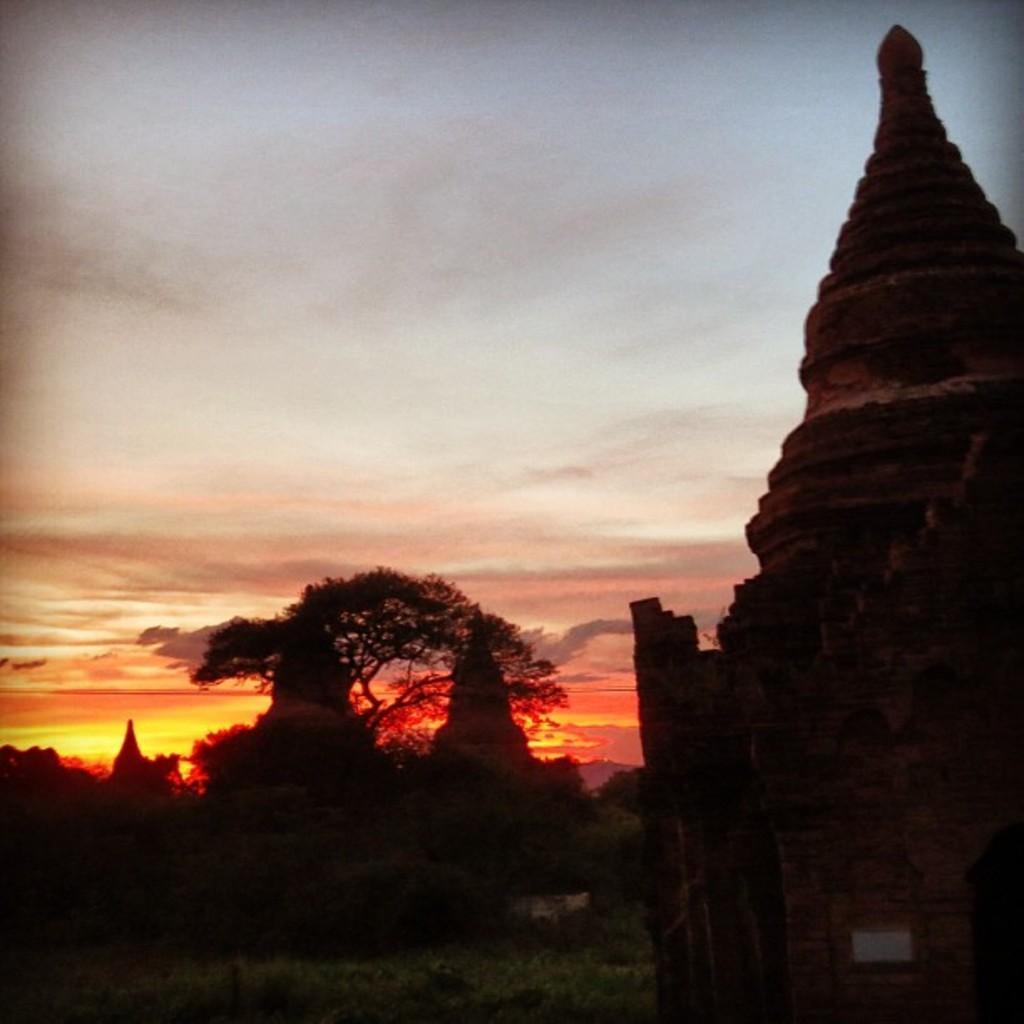Describe this image in one or two sentences. In the background we can see the clouds in the sky. In this picture we can see a tree. It seems like this picture is captured during the evening. Domes are visible. 